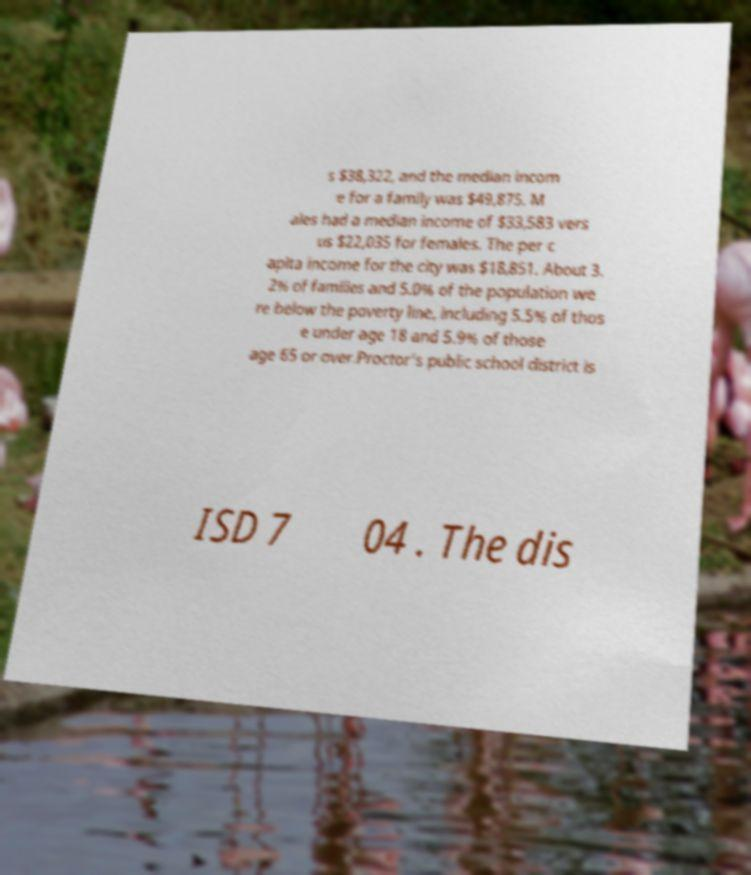What messages or text are displayed in this image? I need them in a readable, typed format. s $38,322, and the median incom e for a family was $49,875. M ales had a median income of $33,583 vers us $22,035 for females. The per c apita income for the city was $18,851. About 3. 2% of families and 5.0% of the population we re below the poverty line, including 5.5% of thos e under age 18 and 5.9% of those age 65 or over.Proctor's public school district is ISD 7 04 . The dis 